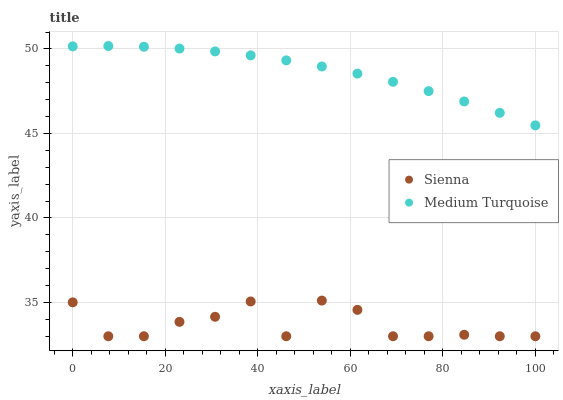Does Sienna have the minimum area under the curve?
Answer yes or no. Yes. Does Medium Turquoise have the maximum area under the curve?
Answer yes or no. Yes. Does Medium Turquoise have the minimum area under the curve?
Answer yes or no. No. Is Medium Turquoise the smoothest?
Answer yes or no. Yes. Is Sienna the roughest?
Answer yes or no. Yes. Is Medium Turquoise the roughest?
Answer yes or no. No. Does Sienna have the lowest value?
Answer yes or no. Yes. Does Medium Turquoise have the lowest value?
Answer yes or no. No. Does Medium Turquoise have the highest value?
Answer yes or no. Yes. Is Sienna less than Medium Turquoise?
Answer yes or no. Yes. Is Medium Turquoise greater than Sienna?
Answer yes or no. Yes. Does Sienna intersect Medium Turquoise?
Answer yes or no. No. 